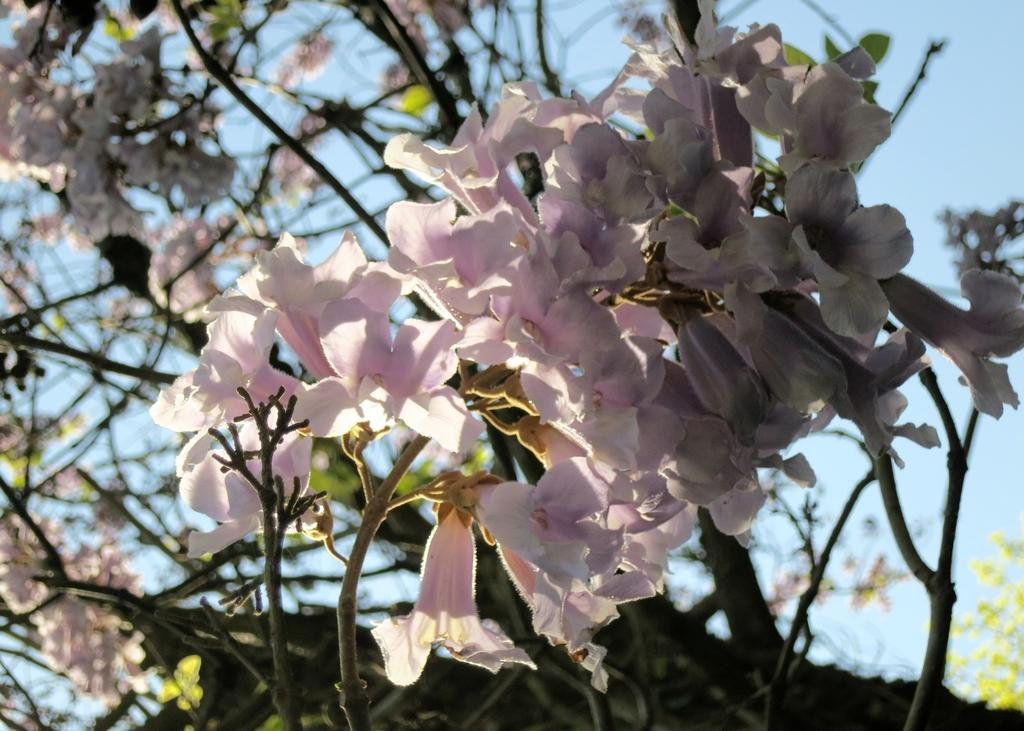What type of plants can be seen in the image? There are flowers in the image. What color are the flowers? The flowers are pink. What else is present in the image besides the flowers? There is a tree in the image. What is the condition of the tree in the image? The tree is flowering. What is visible at the top of the image? The sky is visible at the top of the image. What type of music can be heard playing in the background of the image? There is no music present in the image, as it is a still image of flowers and a tree. 